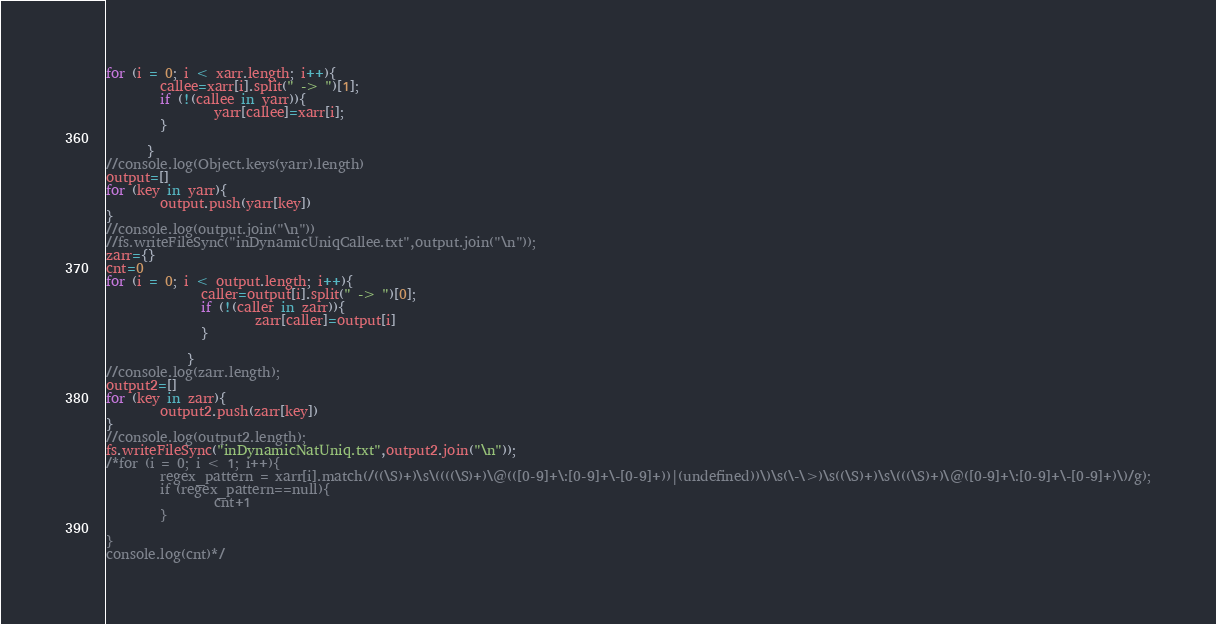<code> <loc_0><loc_0><loc_500><loc_500><_JavaScript_>for (i = 0; i < xarr.length; i++){
        callee=xarr[i].split(" -> ")[1];
        if (!(callee in yarr)){
                yarr[callee]=xarr[i];
        }

      }
//console.log(Object.keys(yarr).length)
output=[]
for (key in yarr){
        output.push(yarr[key])
}
//console.log(output.join("\n"))
//fs.writeFileSync("inDynamicUniqCallee.txt",output.join("\n"));
zarr={}
cnt=0
for (i = 0; i < output.length; i++){
              caller=output[i].split(" -> ")[0];
              if (!(caller in zarr)){
                      zarr[caller]=output[i]
              }
      
            }
//console.log(zarr.length);
output2=[]
for (key in zarr){
        output2.push(zarr[key])
}
//console.log(output2.length);
fs.writeFileSync("inDynamicNatUniq.txt",output2.join("\n"));
/*for (i = 0; i < 1; i++){
        regex_pattern = xarr[i].match(/((\S)+)\s\((((\S)+)\@(([0-9]+\:[0-9]+\-[0-9]+))|(undefined))\)\s(\-\>)\s((\S)+)\s\(((\S)+)\@([0-9]+\:[0-9]+\-[0-9]+)\)/g);
        if (regex_pattern==null){
                cnt+1
        }

}
console.log(cnt)*/</code> 